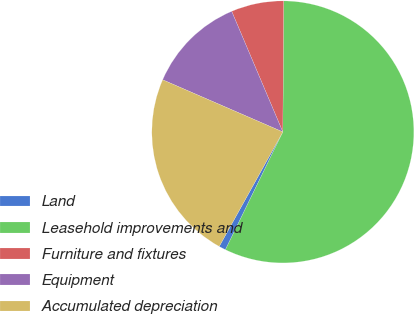Convert chart. <chart><loc_0><loc_0><loc_500><loc_500><pie_chart><fcel>Land<fcel>Leasehold improvements and<fcel>Furniture and fixtures<fcel>Equipment<fcel>Accumulated depreciation<nl><fcel>0.85%<fcel>57.12%<fcel>6.48%<fcel>12.1%<fcel>23.45%<nl></chart> 